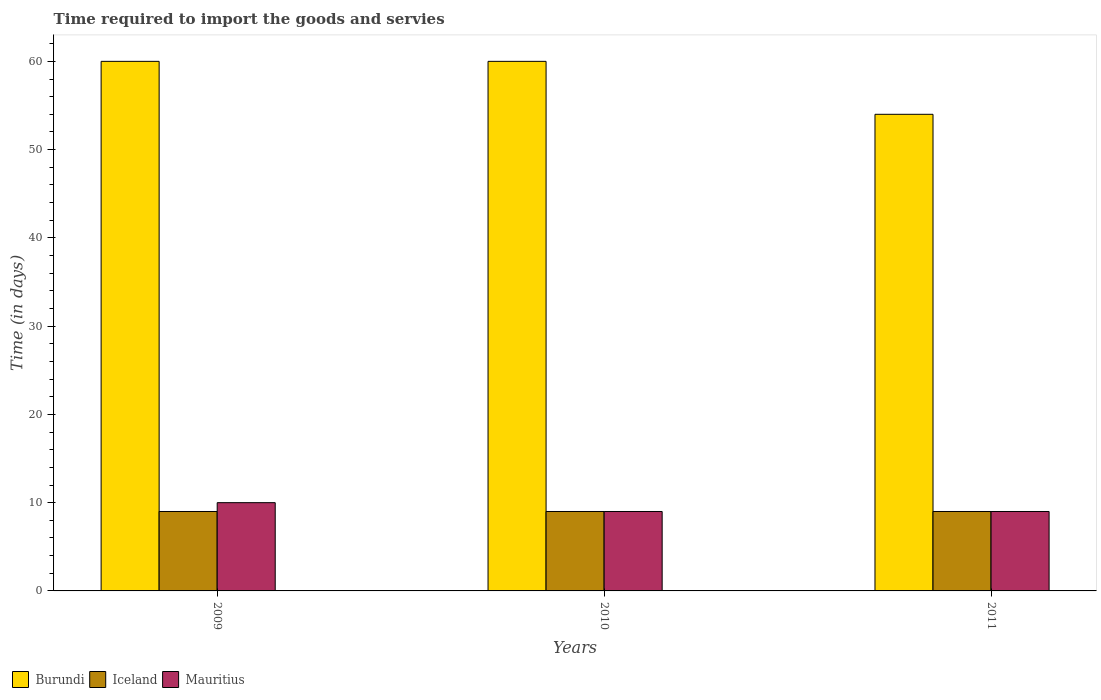How many different coloured bars are there?
Offer a terse response. 3. How many bars are there on the 3rd tick from the right?
Your answer should be very brief. 3. In how many cases, is the number of bars for a given year not equal to the number of legend labels?
Ensure brevity in your answer.  0. What is the number of days required to import the goods and services in Iceland in 2009?
Provide a succinct answer. 9. Across all years, what is the maximum number of days required to import the goods and services in Iceland?
Offer a very short reply. 9. Across all years, what is the minimum number of days required to import the goods and services in Iceland?
Your answer should be compact. 9. In which year was the number of days required to import the goods and services in Iceland maximum?
Provide a short and direct response. 2009. What is the total number of days required to import the goods and services in Mauritius in the graph?
Keep it short and to the point. 28. What is the difference between the number of days required to import the goods and services in Mauritius in 2009 and that in 2011?
Ensure brevity in your answer.  1. What is the difference between the number of days required to import the goods and services in Iceland in 2011 and the number of days required to import the goods and services in Burundi in 2009?
Offer a very short reply. -51. What is the ratio of the number of days required to import the goods and services in Burundi in 2009 to that in 2010?
Make the answer very short. 1. What is the difference between the highest and the second highest number of days required to import the goods and services in Mauritius?
Offer a terse response. 1. What is the difference between the highest and the lowest number of days required to import the goods and services in Mauritius?
Keep it short and to the point. 1. What does the 3rd bar from the left in 2009 represents?
Give a very brief answer. Mauritius. What does the 1st bar from the right in 2010 represents?
Make the answer very short. Mauritius. How many bars are there?
Offer a very short reply. 9. How many years are there in the graph?
Provide a succinct answer. 3. Does the graph contain grids?
Your answer should be compact. No. Where does the legend appear in the graph?
Make the answer very short. Bottom left. How many legend labels are there?
Offer a very short reply. 3. What is the title of the graph?
Your response must be concise. Time required to import the goods and servies. What is the label or title of the Y-axis?
Your answer should be compact. Time (in days). What is the Time (in days) of Iceland in 2009?
Offer a very short reply. 9. What is the Time (in days) of Burundi in 2010?
Make the answer very short. 60. What is the Time (in days) of Iceland in 2010?
Provide a succinct answer. 9. What is the Time (in days) in Mauritius in 2011?
Your response must be concise. 9. Across all years, what is the minimum Time (in days) in Iceland?
Ensure brevity in your answer.  9. What is the total Time (in days) of Burundi in the graph?
Provide a succinct answer. 174. What is the total Time (in days) of Iceland in the graph?
Your response must be concise. 27. What is the total Time (in days) in Mauritius in the graph?
Give a very brief answer. 28. What is the difference between the Time (in days) of Iceland in 2009 and that in 2010?
Provide a succinct answer. 0. What is the difference between the Time (in days) in Mauritius in 2009 and that in 2010?
Your answer should be compact. 1. What is the difference between the Time (in days) of Mauritius in 2010 and that in 2011?
Give a very brief answer. 0. What is the difference between the Time (in days) in Burundi in 2009 and the Time (in days) in Iceland in 2010?
Provide a short and direct response. 51. What is the difference between the Time (in days) of Burundi in 2009 and the Time (in days) of Mauritius in 2010?
Give a very brief answer. 51. What is the difference between the Time (in days) of Iceland in 2009 and the Time (in days) of Mauritius in 2010?
Make the answer very short. 0. What is the difference between the Time (in days) of Burundi in 2009 and the Time (in days) of Iceland in 2011?
Offer a terse response. 51. What is the difference between the Time (in days) of Burundi in 2009 and the Time (in days) of Mauritius in 2011?
Ensure brevity in your answer.  51. What is the difference between the Time (in days) in Burundi in 2010 and the Time (in days) in Iceland in 2011?
Make the answer very short. 51. What is the difference between the Time (in days) in Burundi in 2010 and the Time (in days) in Mauritius in 2011?
Offer a very short reply. 51. What is the average Time (in days) of Burundi per year?
Keep it short and to the point. 58. What is the average Time (in days) of Iceland per year?
Provide a succinct answer. 9. What is the average Time (in days) in Mauritius per year?
Ensure brevity in your answer.  9.33. In the year 2009, what is the difference between the Time (in days) of Iceland and Time (in days) of Mauritius?
Make the answer very short. -1. In the year 2011, what is the difference between the Time (in days) of Burundi and Time (in days) of Iceland?
Provide a succinct answer. 45. In the year 2011, what is the difference between the Time (in days) in Iceland and Time (in days) in Mauritius?
Offer a terse response. 0. What is the ratio of the Time (in days) of Burundi in 2009 to that in 2011?
Your response must be concise. 1.11. What is the ratio of the Time (in days) in Iceland in 2009 to that in 2011?
Offer a very short reply. 1. What is the ratio of the Time (in days) of Mauritius in 2009 to that in 2011?
Offer a very short reply. 1.11. What is the ratio of the Time (in days) in Burundi in 2010 to that in 2011?
Provide a short and direct response. 1.11. What is the ratio of the Time (in days) of Iceland in 2010 to that in 2011?
Provide a succinct answer. 1. What is the difference between the highest and the second highest Time (in days) in Iceland?
Provide a succinct answer. 0. What is the difference between the highest and the second highest Time (in days) of Mauritius?
Offer a terse response. 1. What is the difference between the highest and the lowest Time (in days) of Burundi?
Offer a terse response. 6. What is the difference between the highest and the lowest Time (in days) of Mauritius?
Ensure brevity in your answer.  1. 